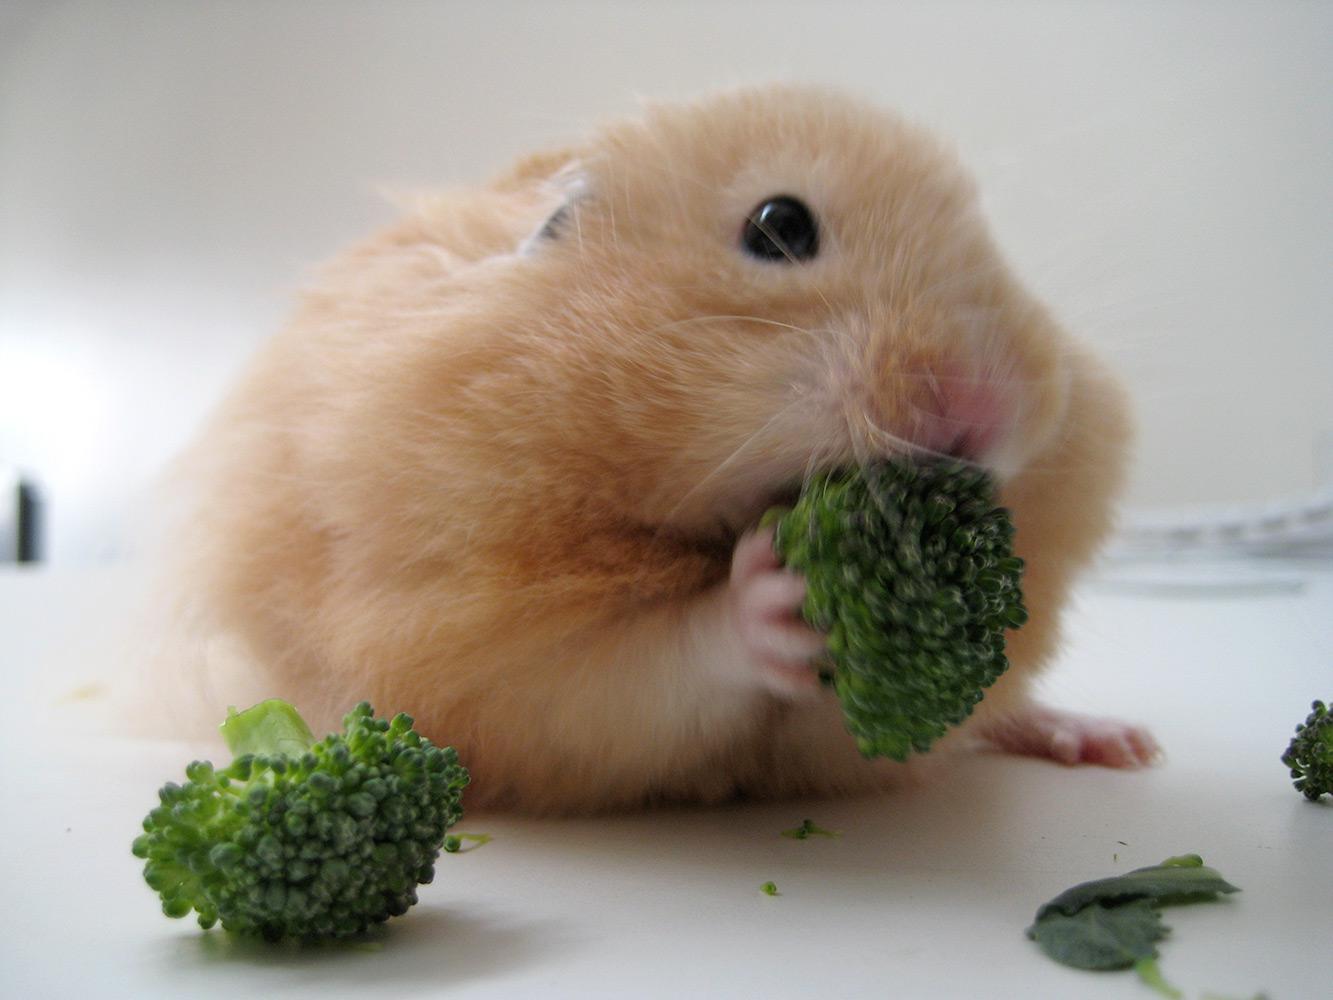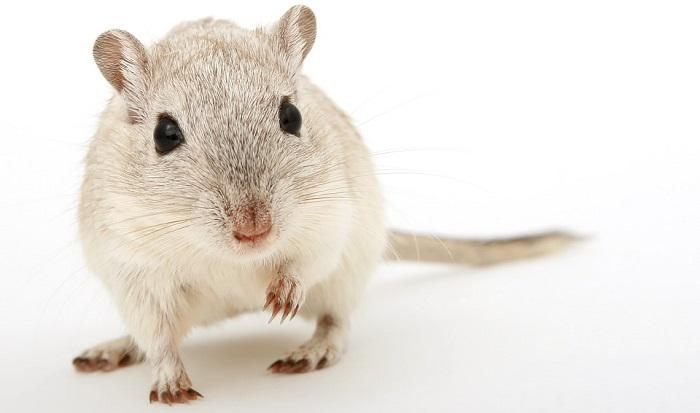The first image is the image on the left, the second image is the image on the right. For the images displayed, is the sentence "The animal in the left image is eating an orange food" factually correct? Answer yes or no. No. The first image is the image on the left, the second image is the image on the right. Analyze the images presented: Is the assertion "All of the hamsters are eating." valid? Answer yes or no. No. 